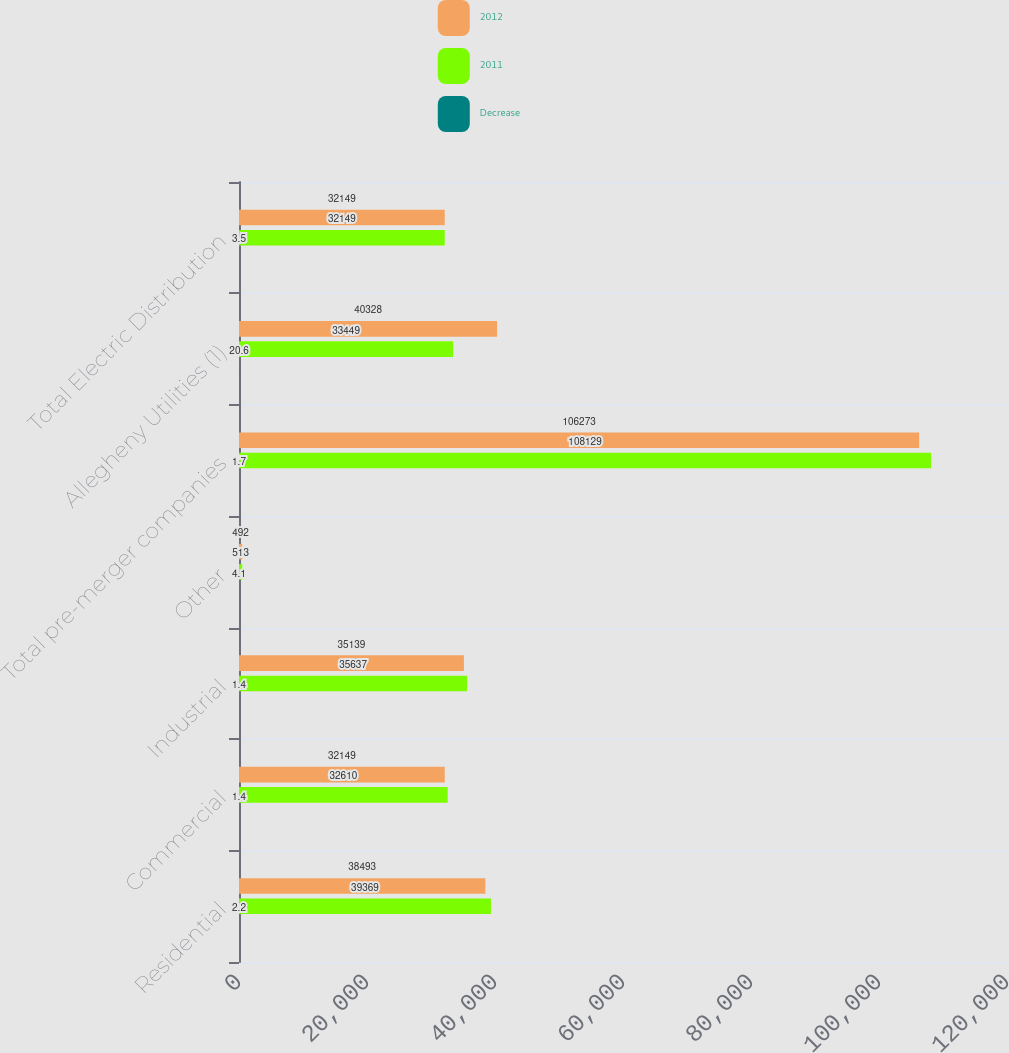Convert chart. <chart><loc_0><loc_0><loc_500><loc_500><stacked_bar_chart><ecel><fcel>Residential<fcel>Commercial<fcel>Industrial<fcel>Other<fcel>Total pre-merger companies<fcel>Allegheny Utilities (1)<fcel>Total Electric Distribution<nl><fcel>2012<fcel>38493<fcel>32149<fcel>35139<fcel>492<fcel>106273<fcel>40328<fcel>32149<nl><fcel>2011<fcel>39369<fcel>32610<fcel>35637<fcel>513<fcel>108129<fcel>33449<fcel>32149<nl><fcel>Decrease<fcel>2.2<fcel>1.4<fcel>1.4<fcel>4.1<fcel>1.7<fcel>20.6<fcel>3.5<nl></chart> 